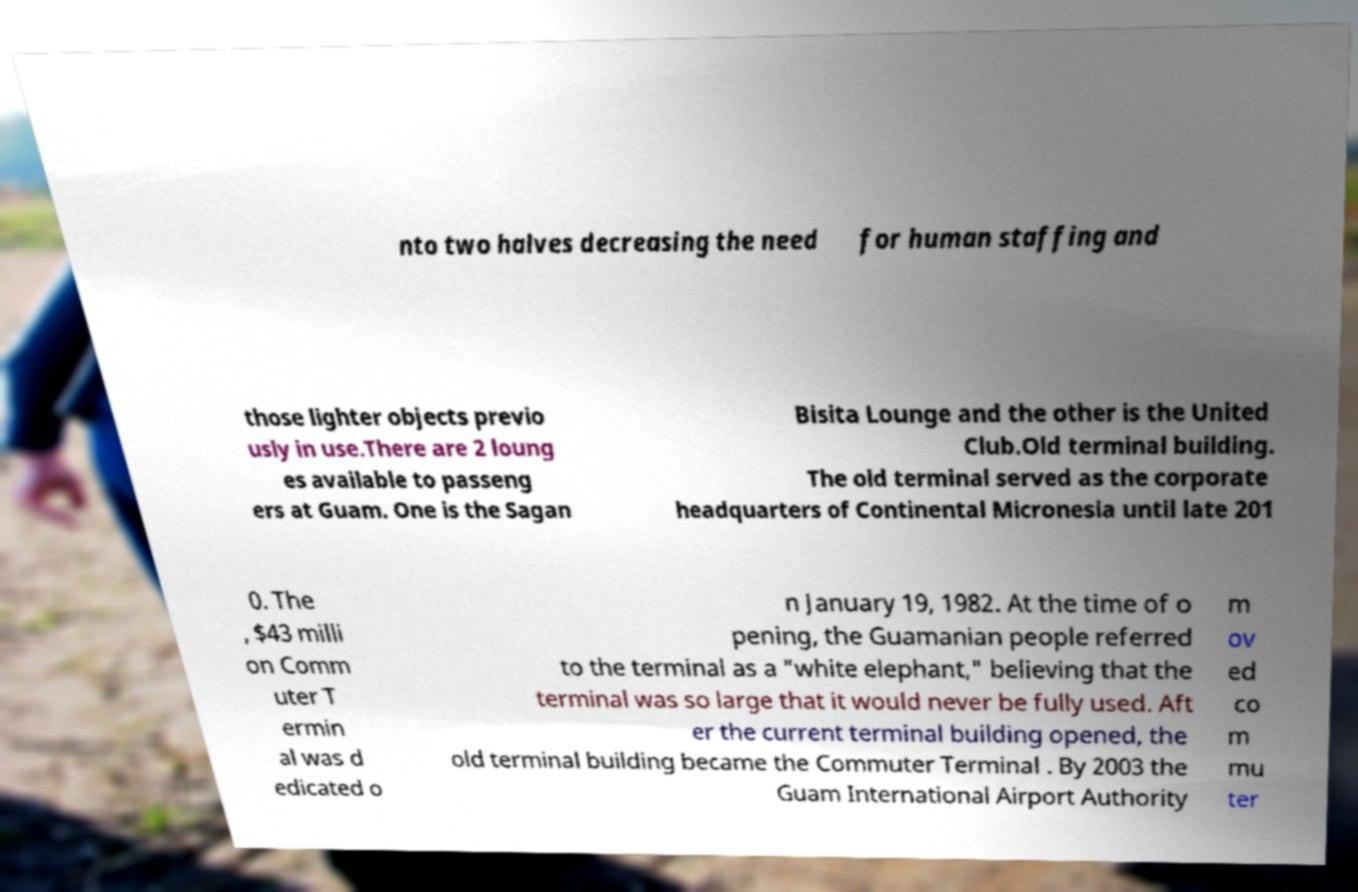Could you extract and type out the text from this image? nto two halves decreasing the need for human staffing and those lighter objects previo usly in use.There are 2 loung es available to passeng ers at Guam. One is the Sagan Bisita Lounge and the other is the United Club.Old terminal building. The old terminal served as the corporate headquarters of Continental Micronesia until late 201 0. The , $43 milli on Comm uter T ermin al was d edicated o n January 19, 1982. At the time of o pening, the Guamanian people referred to the terminal as a "white elephant," believing that the terminal was so large that it would never be fully used. Aft er the current terminal building opened, the old terminal building became the Commuter Terminal . By 2003 the Guam International Airport Authority m ov ed co m mu ter 